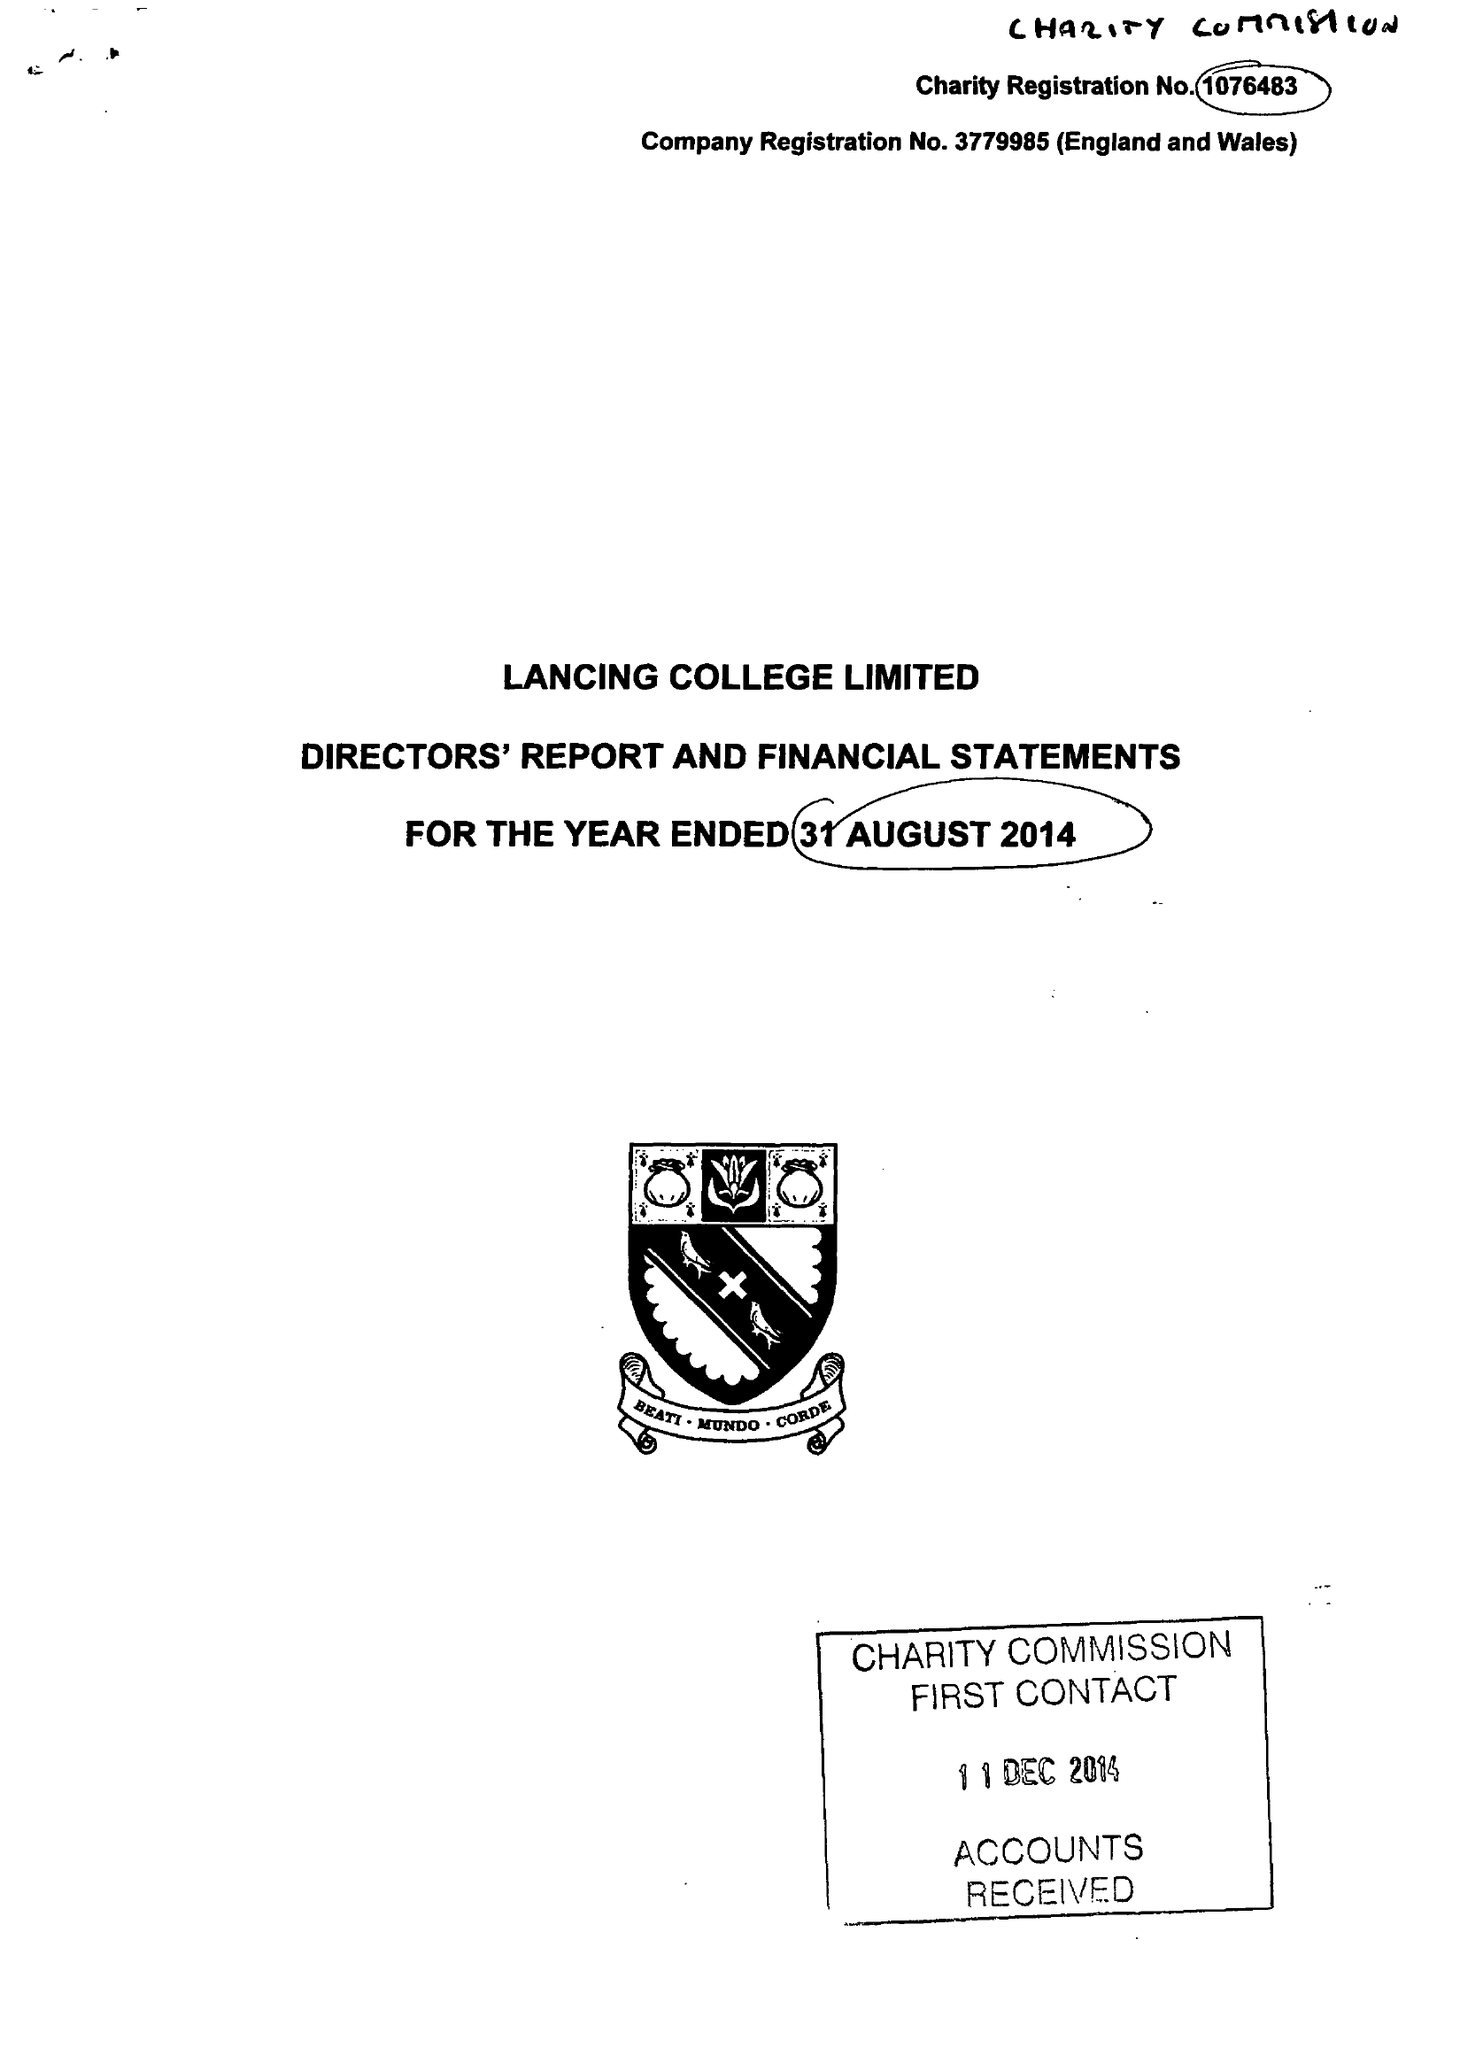What is the value for the address__postcode?
Answer the question using a single word or phrase. BN15 0RW 